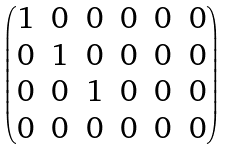Convert formula to latex. <formula><loc_0><loc_0><loc_500><loc_500>\begin{pmatrix} 1 & 0 & 0 & 0 & 0 & 0 \\ 0 & 1 & 0 & 0 & 0 & 0 \\ 0 & 0 & 1 & 0 & 0 & 0 \\ 0 & 0 & 0 & 0 & 0 & 0 \end{pmatrix}</formula> 